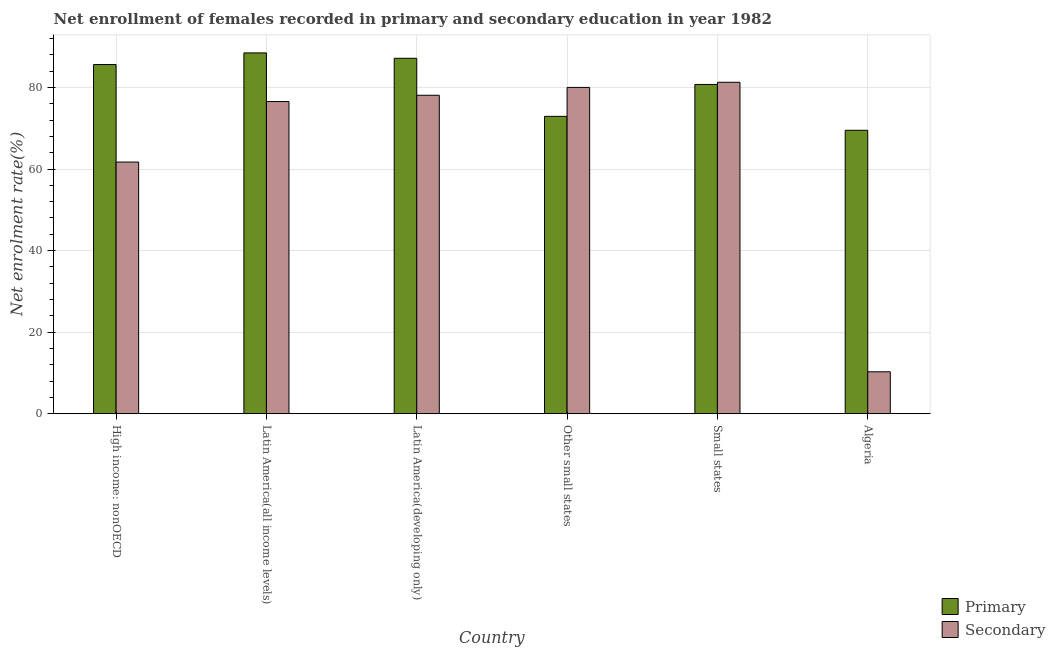How many different coloured bars are there?
Make the answer very short. 2. How many bars are there on the 1st tick from the right?
Provide a succinct answer. 2. What is the label of the 4th group of bars from the left?
Provide a short and direct response. Other small states. What is the enrollment rate in primary education in Other small states?
Your answer should be very brief. 72.92. Across all countries, what is the maximum enrollment rate in primary education?
Provide a succinct answer. 88.47. Across all countries, what is the minimum enrollment rate in primary education?
Provide a succinct answer. 69.51. In which country was the enrollment rate in secondary education maximum?
Ensure brevity in your answer.  Small states. In which country was the enrollment rate in primary education minimum?
Keep it short and to the point. Algeria. What is the total enrollment rate in primary education in the graph?
Provide a succinct answer. 484.4. What is the difference between the enrollment rate in primary education in High income: nonOECD and that in Small states?
Provide a short and direct response. 4.89. What is the difference between the enrollment rate in primary education in Algeria and the enrollment rate in secondary education in High income: nonOECD?
Offer a very short reply. 7.79. What is the average enrollment rate in primary education per country?
Offer a very short reply. 80.73. What is the difference between the enrollment rate in secondary education and enrollment rate in primary education in Small states?
Make the answer very short. 0.54. What is the ratio of the enrollment rate in secondary education in Algeria to that in Latin America(developing only)?
Offer a very short reply. 0.13. What is the difference between the highest and the second highest enrollment rate in primary education?
Give a very brief answer. 1.32. What is the difference between the highest and the lowest enrollment rate in secondary education?
Your answer should be compact. 70.99. Is the sum of the enrollment rate in primary education in High income: nonOECD and Latin America(all income levels) greater than the maximum enrollment rate in secondary education across all countries?
Your response must be concise. Yes. What does the 1st bar from the left in Other small states represents?
Provide a succinct answer. Primary. What does the 2nd bar from the right in Small states represents?
Provide a succinct answer. Primary. Does the graph contain any zero values?
Offer a terse response. No. Does the graph contain grids?
Your answer should be very brief. Yes. How are the legend labels stacked?
Offer a terse response. Vertical. What is the title of the graph?
Provide a short and direct response. Net enrollment of females recorded in primary and secondary education in year 1982. What is the label or title of the X-axis?
Provide a short and direct response. Country. What is the label or title of the Y-axis?
Your answer should be compact. Net enrolment rate(%). What is the Net enrolment rate(%) of Primary in High income: nonOECD?
Give a very brief answer. 85.62. What is the Net enrolment rate(%) of Secondary in High income: nonOECD?
Give a very brief answer. 61.71. What is the Net enrolment rate(%) of Primary in Latin America(all income levels)?
Provide a short and direct response. 88.47. What is the Net enrolment rate(%) in Secondary in Latin America(all income levels)?
Your answer should be very brief. 76.54. What is the Net enrolment rate(%) in Primary in Latin America(developing only)?
Offer a very short reply. 87.15. What is the Net enrolment rate(%) of Secondary in Latin America(developing only)?
Your answer should be compact. 78.09. What is the Net enrolment rate(%) in Primary in Other small states?
Offer a very short reply. 72.92. What is the Net enrolment rate(%) of Secondary in Other small states?
Your answer should be very brief. 80.01. What is the Net enrolment rate(%) in Primary in Small states?
Your response must be concise. 80.74. What is the Net enrolment rate(%) in Secondary in Small states?
Give a very brief answer. 81.28. What is the Net enrolment rate(%) of Primary in Algeria?
Make the answer very short. 69.51. What is the Net enrolment rate(%) of Secondary in Algeria?
Keep it short and to the point. 10.29. Across all countries, what is the maximum Net enrolment rate(%) of Primary?
Ensure brevity in your answer.  88.47. Across all countries, what is the maximum Net enrolment rate(%) in Secondary?
Offer a terse response. 81.28. Across all countries, what is the minimum Net enrolment rate(%) of Primary?
Your answer should be very brief. 69.51. Across all countries, what is the minimum Net enrolment rate(%) of Secondary?
Your answer should be very brief. 10.29. What is the total Net enrolment rate(%) in Primary in the graph?
Make the answer very short. 484.4. What is the total Net enrolment rate(%) in Secondary in the graph?
Provide a succinct answer. 387.92. What is the difference between the Net enrolment rate(%) in Primary in High income: nonOECD and that in Latin America(all income levels)?
Offer a very short reply. -2.85. What is the difference between the Net enrolment rate(%) of Secondary in High income: nonOECD and that in Latin America(all income levels)?
Make the answer very short. -14.83. What is the difference between the Net enrolment rate(%) of Primary in High income: nonOECD and that in Latin America(developing only)?
Ensure brevity in your answer.  -1.53. What is the difference between the Net enrolment rate(%) of Secondary in High income: nonOECD and that in Latin America(developing only)?
Provide a short and direct response. -16.37. What is the difference between the Net enrolment rate(%) in Primary in High income: nonOECD and that in Other small states?
Your answer should be very brief. 12.7. What is the difference between the Net enrolment rate(%) of Secondary in High income: nonOECD and that in Other small states?
Your answer should be very brief. -18.3. What is the difference between the Net enrolment rate(%) in Primary in High income: nonOECD and that in Small states?
Offer a terse response. 4.89. What is the difference between the Net enrolment rate(%) in Secondary in High income: nonOECD and that in Small states?
Make the answer very short. -19.56. What is the difference between the Net enrolment rate(%) of Primary in High income: nonOECD and that in Algeria?
Your answer should be compact. 16.12. What is the difference between the Net enrolment rate(%) of Secondary in High income: nonOECD and that in Algeria?
Offer a terse response. 51.43. What is the difference between the Net enrolment rate(%) of Primary in Latin America(all income levels) and that in Latin America(developing only)?
Your answer should be very brief. 1.32. What is the difference between the Net enrolment rate(%) of Secondary in Latin America(all income levels) and that in Latin America(developing only)?
Provide a succinct answer. -1.54. What is the difference between the Net enrolment rate(%) in Primary in Latin America(all income levels) and that in Other small states?
Ensure brevity in your answer.  15.55. What is the difference between the Net enrolment rate(%) in Secondary in Latin America(all income levels) and that in Other small states?
Your response must be concise. -3.47. What is the difference between the Net enrolment rate(%) in Primary in Latin America(all income levels) and that in Small states?
Keep it short and to the point. 7.74. What is the difference between the Net enrolment rate(%) of Secondary in Latin America(all income levels) and that in Small states?
Your answer should be very brief. -4.73. What is the difference between the Net enrolment rate(%) of Primary in Latin America(all income levels) and that in Algeria?
Your answer should be very brief. 18.97. What is the difference between the Net enrolment rate(%) of Secondary in Latin America(all income levels) and that in Algeria?
Ensure brevity in your answer.  66.26. What is the difference between the Net enrolment rate(%) in Primary in Latin America(developing only) and that in Other small states?
Keep it short and to the point. 14.23. What is the difference between the Net enrolment rate(%) in Secondary in Latin America(developing only) and that in Other small states?
Your answer should be very brief. -1.93. What is the difference between the Net enrolment rate(%) in Primary in Latin America(developing only) and that in Small states?
Your answer should be compact. 6.42. What is the difference between the Net enrolment rate(%) in Secondary in Latin America(developing only) and that in Small states?
Your response must be concise. -3.19. What is the difference between the Net enrolment rate(%) of Primary in Latin America(developing only) and that in Algeria?
Offer a terse response. 17.65. What is the difference between the Net enrolment rate(%) of Secondary in Latin America(developing only) and that in Algeria?
Offer a terse response. 67.8. What is the difference between the Net enrolment rate(%) in Primary in Other small states and that in Small states?
Your response must be concise. -7.82. What is the difference between the Net enrolment rate(%) in Secondary in Other small states and that in Small states?
Offer a terse response. -1.26. What is the difference between the Net enrolment rate(%) of Primary in Other small states and that in Algeria?
Give a very brief answer. 3.41. What is the difference between the Net enrolment rate(%) in Secondary in Other small states and that in Algeria?
Give a very brief answer. 69.73. What is the difference between the Net enrolment rate(%) of Primary in Small states and that in Algeria?
Keep it short and to the point. 11.23. What is the difference between the Net enrolment rate(%) of Secondary in Small states and that in Algeria?
Your answer should be compact. 70.99. What is the difference between the Net enrolment rate(%) in Primary in High income: nonOECD and the Net enrolment rate(%) in Secondary in Latin America(all income levels)?
Your response must be concise. 9.08. What is the difference between the Net enrolment rate(%) of Primary in High income: nonOECD and the Net enrolment rate(%) of Secondary in Latin America(developing only)?
Give a very brief answer. 7.54. What is the difference between the Net enrolment rate(%) in Primary in High income: nonOECD and the Net enrolment rate(%) in Secondary in Other small states?
Provide a short and direct response. 5.61. What is the difference between the Net enrolment rate(%) in Primary in High income: nonOECD and the Net enrolment rate(%) in Secondary in Small states?
Give a very brief answer. 4.35. What is the difference between the Net enrolment rate(%) in Primary in High income: nonOECD and the Net enrolment rate(%) in Secondary in Algeria?
Provide a short and direct response. 75.34. What is the difference between the Net enrolment rate(%) of Primary in Latin America(all income levels) and the Net enrolment rate(%) of Secondary in Latin America(developing only)?
Your response must be concise. 10.39. What is the difference between the Net enrolment rate(%) of Primary in Latin America(all income levels) and the Net enrolment rate(%) of Secondary in Other small states?
Offer a terse response. 8.46. What is the difference between the Net enrolment rate(%) in Primary in Latin America(all income levels) and the Net enrolment rate(%) in Secondary in Small states?
Ensure brevity in your answer.  7.2. What is the difference between the Net enrolment rate(%) of Primary in Latin America(all income levels) and the Net enrolment rate(%) of Secondary in Algeria?
Your response must be concise. 78.19. What is the difference between the Net enrolment rate(%) in Primary in Latin America(developing only) and the Net enrolment rate(%) in Secondary in Other small states?
Offer a very short reply. 7.14. What is the difference between the Net enrolment rate(%) of Primary in Latin America(developing only) and the Net enrolment rate(%) of Secondary in Small states?
Ensure brevity in your answer.  5.88. What is the difference between the Net enrolment rate(%) in Primary in Latin America(developing only) and the Net enrolment rate(%) in Secondary in Algeria?
Keep it short and to the point. 76.87. What is the difference between the Net enrolment rate(%) in Primary in Other small states and the Net enrolment rate(%) in Secondary in Small states?
Offer a very short reply. -8.36. What is the difference between the Net enrolment rate(%) in Primary in Other small states and the Net enrolment rate(%) in Secondary in Algeria?
Give a very brief answer. 62.63. What is the difference between the Net enrolment rate(%) of Primary in Small states and the Net enrolment rate(%) of Secondary in Algeria?
Your answer should be compact. 70.45. What is the average Net enrolment rate(%) in Primary per country?
Make the answer very short. 80.73. What is the average Net enrolment rate(%) of Secondary per country?
Your answer should be compact. 64.65. What is the difference between the Net enrolment rate(%) in Primary and Net enrolment rate(%) in Secondary in High income: nonOECD?
Keep it short and to the point. 23.91. What is the difference between the Net enrolment rate(%) of Primary and Net enrolment rate(%) of Secondary in Latin America(all income levels)?
Your answer should be very brief. 11.93. What is the difference between the Net enrolment rate(%) in Primary and Net enrolment rate(%) in Secondary in Latin America(developing only)?
Your answer should be compact. 9.07. What is the difference between the Net enrolment rate(%) of Primary and Net enrolment rate(%) of Secondary in Other small states?
Provide a succinct answer. -7.1. What is the difference between the Net enrolment rate(%) of Primary and Net enrolment rate(%) of Secondary in Small states?
Ensure brevity in your answer.  -0.54. What is the difference between the Net enrolment rate(%) in Primary and Net enrolment rate(%) in Secondary in Algeria?
Your answer should be compact. 59.22. What is the ratio of the Net enrolment rate(%) of Primary in High income: nonOECD to that in Latin America(all income levels)?
Make the answer very short. 0.97. What is the ratio of the Net enrolment rate(%) of Secondary in High income: nonOECD to that in Latin America(all income levels)?
Your answer should be very brief. 0.81. What is the ratio of the Net enrolment rate(%) in Primary in High income: nonOECD to that in Latin America(developing only)?
Provide a short and direct response. 0.98. What is the ratio of the Net enrolment rate(%) of Secondary in High income: nonOECD to that in Latin America(developing only)?
Provide a short and direct response. 0.79. What is the ratio of the Net enrolment rate(%) in Primary in High income: nonOECD to that in Other small states?
Ensure brevity in your answer.  1.17. What is the ratio of the Net enrolment rate(%) of Secondary in High income: nonOECD to that in Other small states?
Keep it short and to the point. 0.77. What is the ratio of the Net enrolment rate(%) of Primary in High income: nonOECD to that in Small states?
Your answer should be compact. 1.06. What is the ratio of the Net enrolment rate(%) of Secondary in High income: nonOECD to that in Small states?
Your answer should be very brief. 0.76. What is the ratio of the Net enrolment rate(%) of Primary in High income: nonOECD to that in Algeria?
Your response must be concise. 1.23. What is the ratio of the Net enrolment rate(%) of Secondary in High income: nonOECD to that in Algeria?
Your response must be concise. 6. What is the ratio of the Net enrolment rate(%) of Primary in Latin America(all income levels) to that in Latin America(developing only)?
Offer a terse response. 1.02. What is the ratio of the Net enrolment rate(%) of Secondary in Latin America(all income levels) to that in Latin America(developing only)?
Provide a short and direct response. 0.98. What is the ratio of the Net enrolment rate(%) in Primary in Latin America(all income levels) to that in Other small states?
Ensure brevity in your answer.  1.21. What is the ratio of the Net enrolment rate(%) in Secondary in Latin America(all income levels) to that in Other small states?
Keep it short and to the point. 0.96. What is the ratio of the Net enrolment rate(%) in Primary in Latin America(all income levels) to that in Small states?
Provide a short and direct response. 1.1. What is the ratio of the Net enrolment rate(%) of Secondary in Latin America(all income levels) to that in Small states?
Your answer should be compact. 0.94. What is the ratio of the Net enrolment rate(%) in Primary in Latin America(all income levels) to that in Algeria?
Keep it short and to the point. 1.27. What is the ratio of the Net enrolment rate(%) in Secondary in Latin America(all income levels) to that in Algeria?
Offer a very short reply. 7.44. What is the ratio of the Net enrolment rate(%) in Primary in Latin America(developing only) to that in Other small states?
Offer a terse response. 1.2. What is the ratio of the Net enrolment rate(%) of Secondary in Latin America(developing only) to that in Other small states?
Provide a short and direct response. 0.98. What is the ratio of the Net enrolment rate(%) of Primary in Latin America(developing only) to that in Small states?
Your answer should be compact. 1.08. What is the ratio of the Net enrolment rate(%) of Secondary in Latin America(developing only) to that in Small states?
Make the answer very short. 0.96. What is the ratio of the Net enrolment rate(%) in Primary in Latin America(developing only) to that in Algeria?
Make the answer very short. 1.25. What is the ratio of the Net enrolment rate(%) in Secondary in Latin America(developing only) to that in Algeria?
Offer a terse response. 7.59. What is the ratio of the Net enrolment rate(%) of Primary in Other small states to that in Small states?
Provide a succinct answer. 0.9. What is the ratio of the Net enrolment rate(%) in Secondary in Other small states to that in Small states?
Your response must be concise. 0.98. What is the ratio of the Net enrolment rate(%) in Primary in Other small states to that in Algeria?
Offer a very short reply. 1.05. What is the ratio of the Net enrolment rate(%) in Secondary in Other small states to that in Algeria?
Make the answer very short. 7.78. What is the ratio of the Net enrolment rate(%) of Primary in Small states to that in Algeria?
Ensure brevity in your answer.  1.16. What is the ratio of the Net enrolment rate(%) of Secondary in Small states to that in Algeria?
Ensure brevity in your answer.  7.9. What is the difference between the highest and the second highest Net enrolment rate(%) in Primary?
Provide a succinct answer. 1.32. What is the difference between the highest and the second highest Net enrolment rate(%) of Secondary?
Provide a succinct answer. 1.26. What is the difference between the highest and the lowest Net enrolment rate(%) in Primary?
Your response must be concise. 18.97. What is the difference between the highest and the lowest Net enrolment rate(%) in Secondary?
Give a very brief answer. 70.99. 